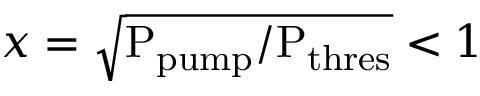<formula> <loc_0><loc_0><loc_500><loc_500>x = \sqrt { P _ { p u m p } / P _ { t h r e s } } < 1</formula> 